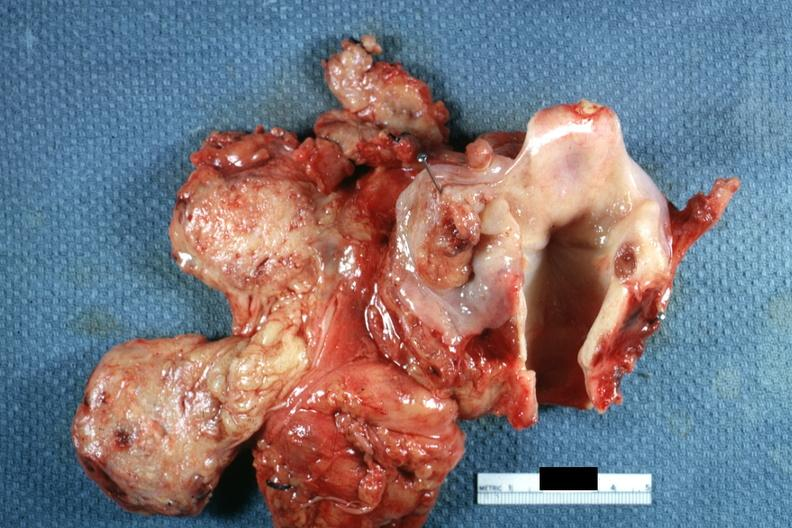s squamous cell carcinoma present?
Answer the question using a single word or phrase. Yes 